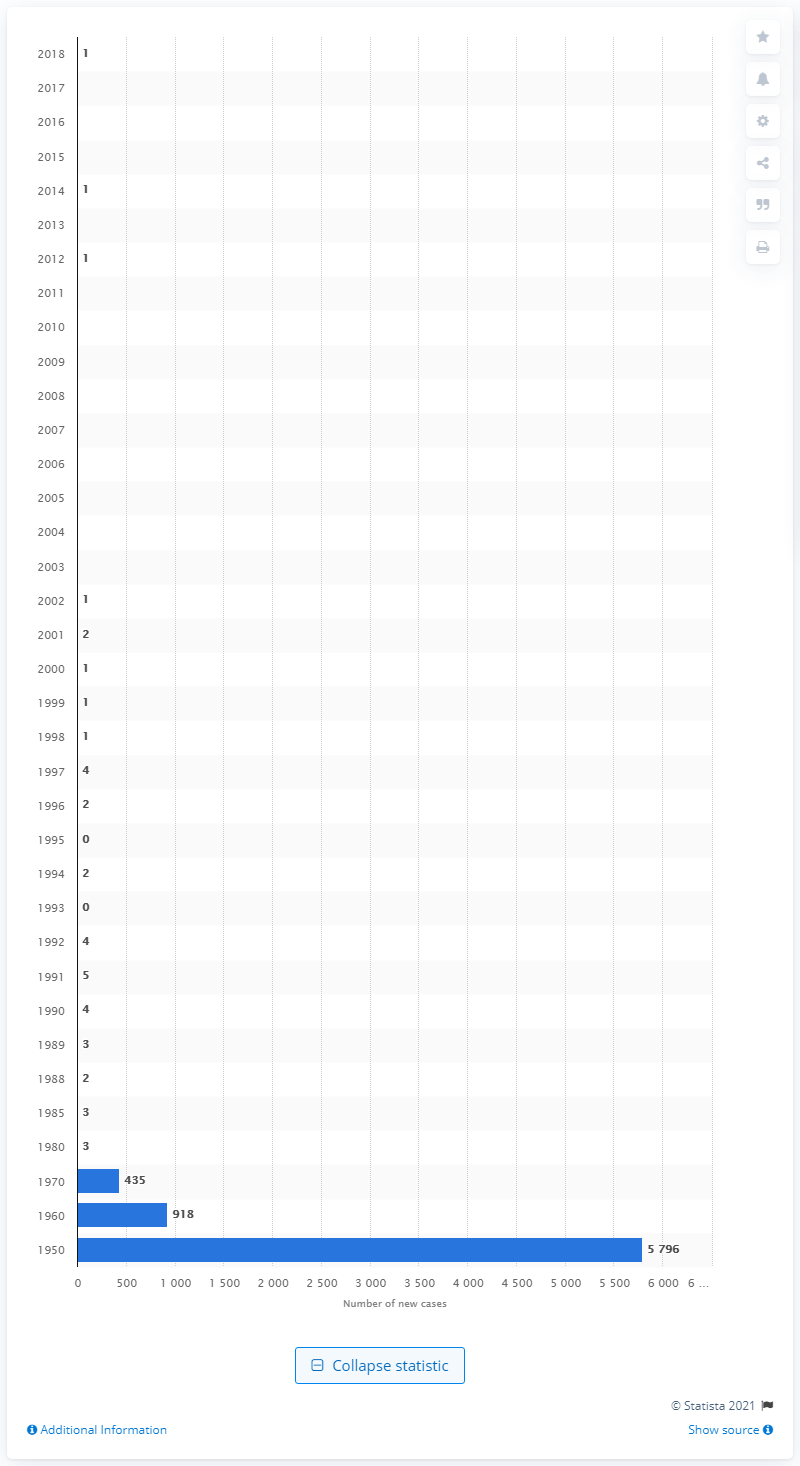Indicate a few pertinent items in this graphic. During the period of 1950 to 2018 in the United States, there were a total of 1 new case of diphtheria reported. In 1970, there were 435 new cases of diphtheria in the United States. 